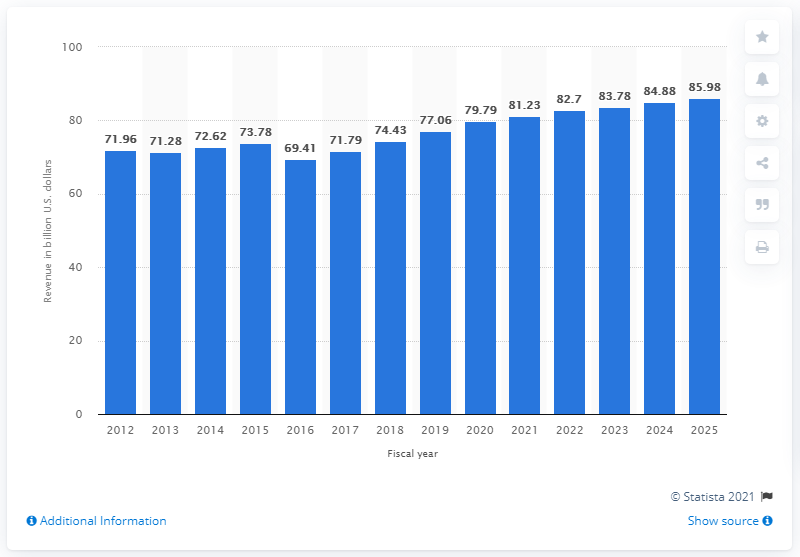Highlight a few significant elements in this photo. Target's projected revenue for the United States in 2025 was $85.98. Target's U.S. revenue in 2019 was $77.06 billion. In 2025, Target's U.S. revenue was forecasted to reach 85.98 billion U.S. dollars. 